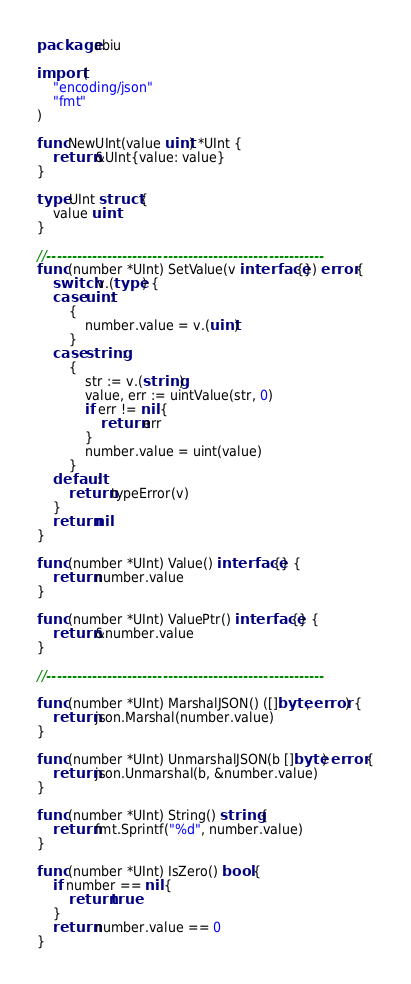<code> <loc_0><loc_0><loc_500><loc_500><_Go_>package abiu

import (
	"encoding/json"
	"fmt"
)

func NewUInt(value uint) *UInt {
	return &UInt{value: value}
}

type UInt struct {
	value uint
}

//-------------------------------------------------------
func (number *UInt) SetValue(v interface{}) error {
	switch v.(type) {
	case uint:
		{
			number.value = v.(uint)
		}
	case string:
		{
			str := v.(string)
			value, err := uintValue(str, 0)
			if err != nil {
				return err
			}
			number.value = uint(value)
		}
	default:
		return typeError(v)
	}
	return nil
}

func (number *UInt) Value() interface{} {
	return number.value
}

func (number *UInt) ValuePtr() interface{} {
	return &number.value
}

//-------------------------------------------------------

func (number *UInt) MarshalJSON() ([]byte, error) {
	return json.Marshal(number.value)
}

func (number *UInt) UnmarshalJSON(b []byte) error {
	return json.Unmarshal(b, &number.value)
}

func (number *UInt) String() string {
	return fmt.Sprintf("%d", number.value)
}

func (number *UInt) IsZero() bool {
	if number == nil {
		return true
	}
	return number.value == 0
}
</code> 